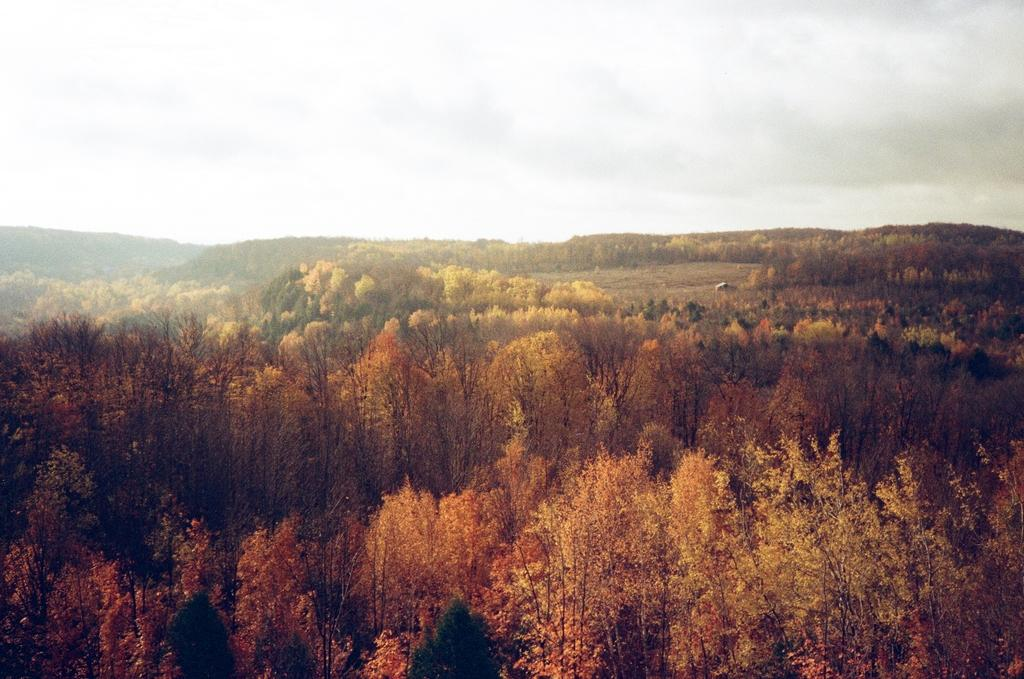What type of view is shown in the image? The image is an aerial view. What geographical features can be seen in the image? There are hills visible in the image. What type of vegetation is present in the image? There are trees in the image. What is visible in the sky at the top of the image? Clouds are present in the sky at the top of the image. How does the fan help to cool down the trees in the image? There is no fan present in the image, so it cannot help to cool down the trees. 